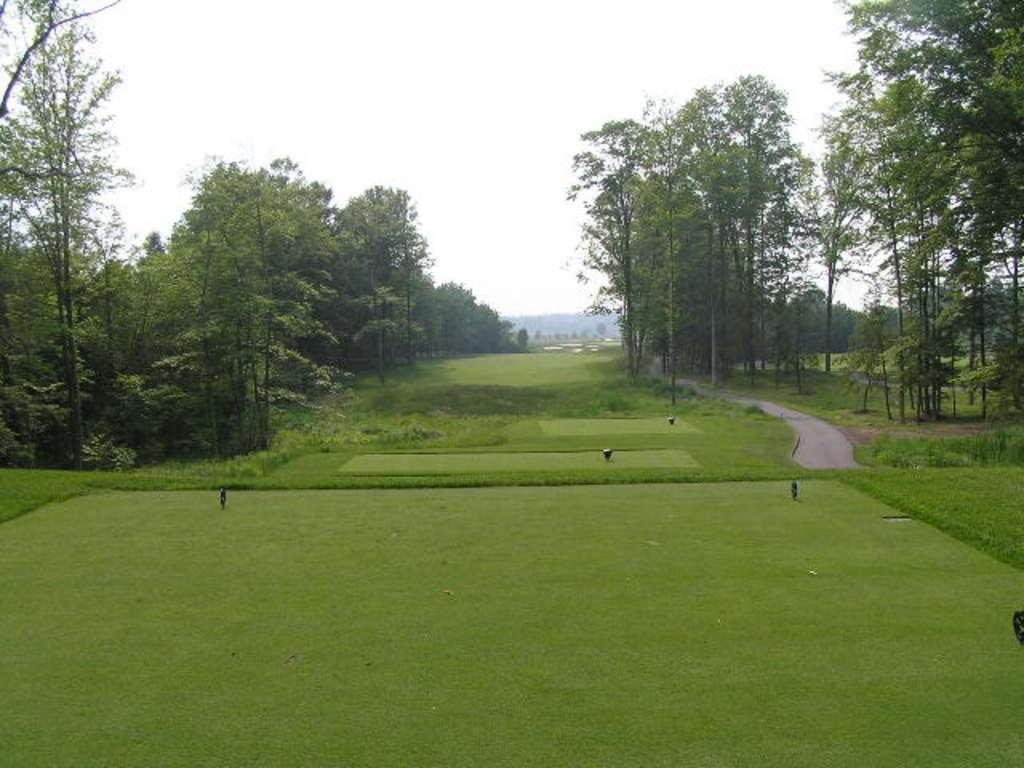What type of vegetation is present on the ground in the image? There is grass on the ground in the image. What other natural elements can be seen in the image? There are trees in the image. What can be seen in the distance in the image? The sky is visible in the background of the image. What type of account is being discussed in the image? There is no account being discussed in the image; it features grass, trees, and the sky. 